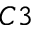Convert formula to latex. <formula><loc_0><loc_0><loc_500><loc_500>C 3</formula> 